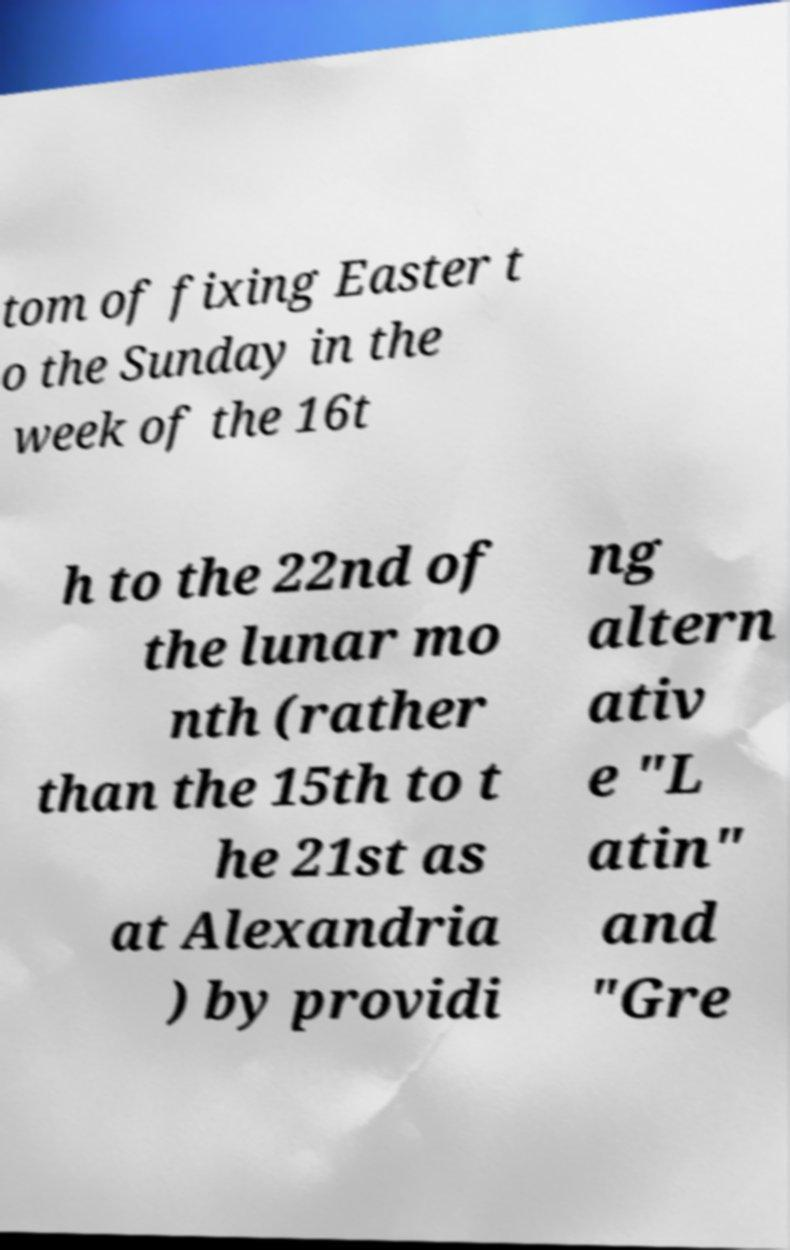There's text embedded in this image that I need extracted. Can you transcribe it verbatim? tom of fixing Easter t o the Sunday in the week of the 16t h to the 22nd of the lunar mo nth (rather than the 15th to t he 21st as at Alexandria ) by providi ng altern ativ e "L atin" and "Gre 